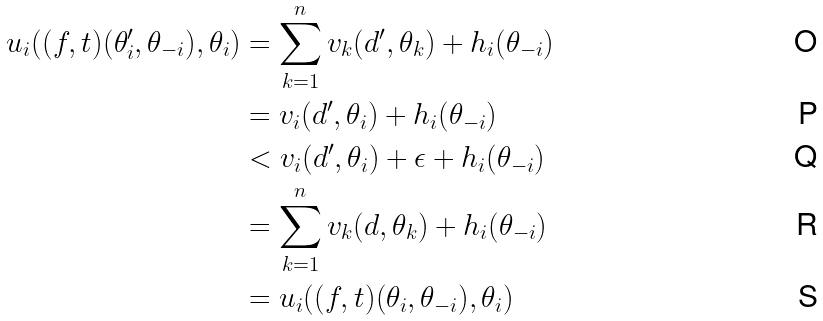<formula> <loc_0><loc_0><loc_500><loc_500>u _ { i } ( ( f , t ) ( \theta ^ { \prime } _ { i } , \theta _ { - i } ) , \theta _ { i } ) & = \sum _ { k = 1 } ^ { n } v _ { k } ( d ^ { \prime } , \theta _ { k } ) + h _ { i } ( \theta _ { - i } ) \\ & = v _ { i } ( d ^ { \prime } , \theta _ { i } ) + h _ { i } ( \theta _ { - i } ) \\ & < v _ { i } ( d ^ { \prime } , \theta _ { i } ) + \epsilon + h _ { i } ( \theta _ { - i } ) \\ & = \sum _ { k = 1 } ^ { n } v _ { k } ( d , \theta _ { k } ) + h _ { i } ( \theta _ { - i } ) \\ & = u _ { i } ( ( f , t ) ( \theta _ { i } , \theta _ { - i } ) , \theta _ { i } )</formula> 